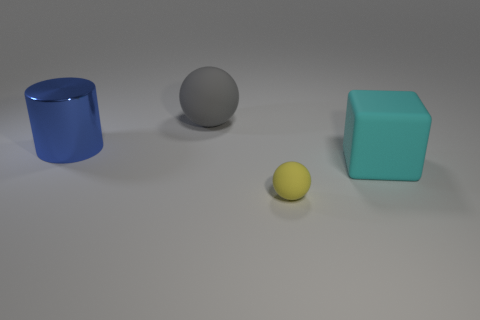What colors are the objects in the image? The objects are of four distinct colors. Starting from the left, we have a blue cylinder, a gray sphere, a yellow sphere, and a turquoise cube. 